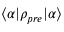Convert formula to latex. <formula><loc_0><loc_0><loc_500><loc_500>\langle \alpha | \rho _ { p r e } | \alpha \rangle</formula> 